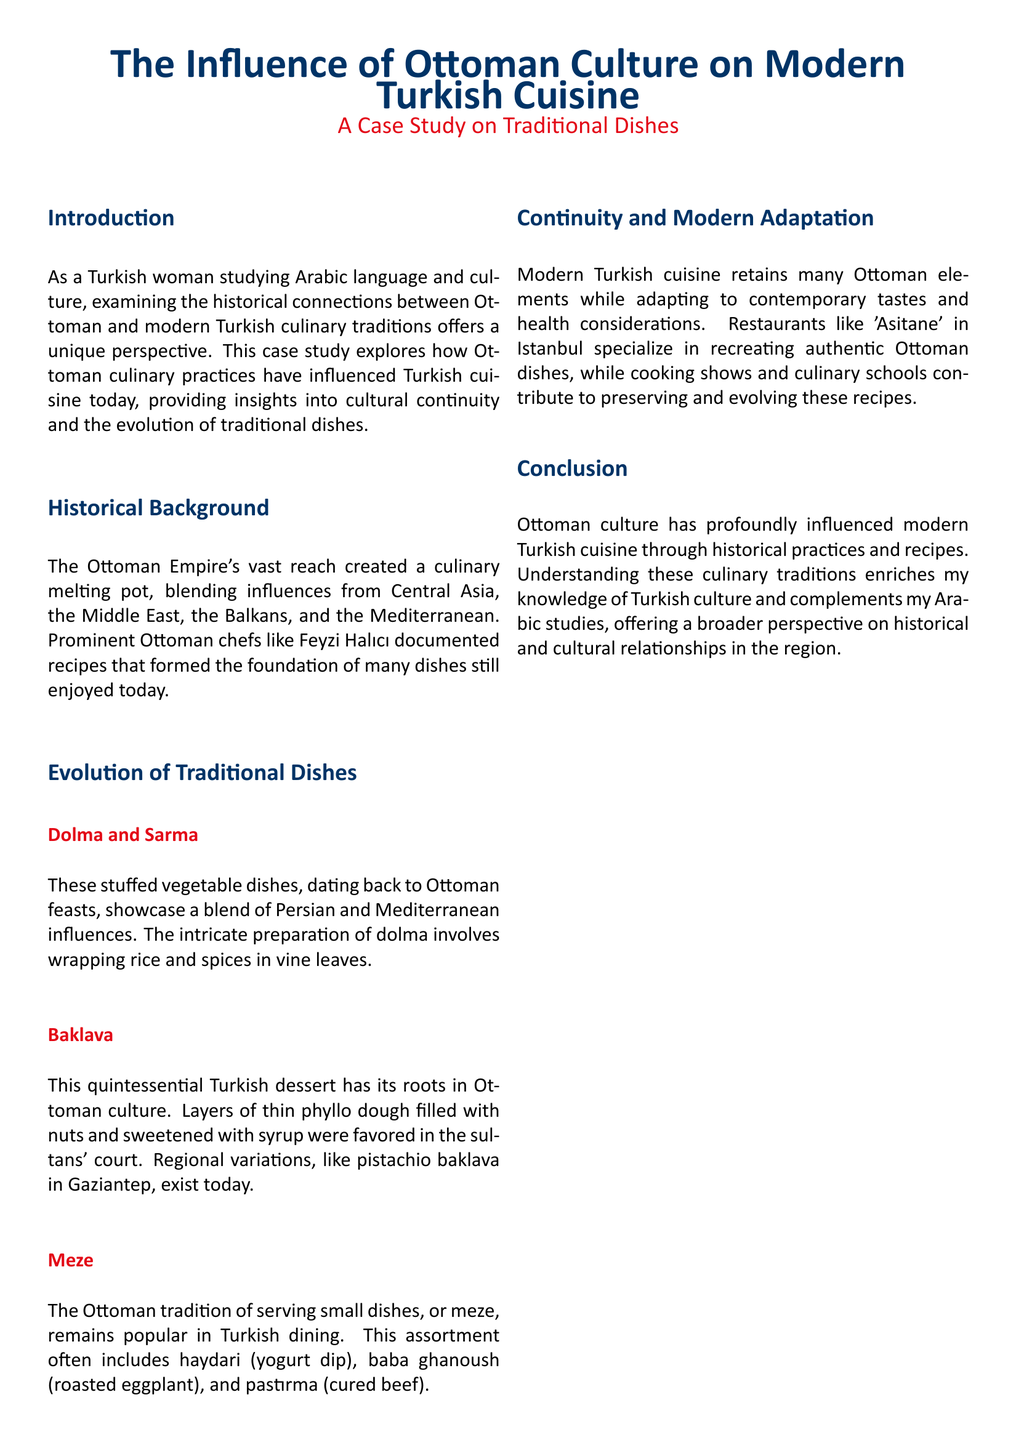What is the main focus of the case study? The case study focuses on the influence of Ottoman culture on modern Turkish cuisine by examining traditional dishes.
Answer: Influence of Ottoman culture on modern Turkish cuisine Who documented the recipes that formed the foundation of many dishes? Prominent Ottoman chefs like Feyzi Halıcı documented recipes that are foundational to many dishes today.
Answer: Feyzi Halıcı What type of dish are dolma and sarma? Dolma and sarma are stuffed vegetable dishes that date back to Ottoman feasts.
Answer: Stuffed vegetable dishes Which dessert is rooted in Ottoman culture? Baklava is the quintessential Turkish dessert with roots in Ottoman culture.
Answer: Baklava What is a common feature of modern Turkish cuisine? Modern Turkish cuisine retains many Ottoman elements and adapts to contemporary tastes.
Answer: Retains many Ottoman elements What is the name of the restaurant in Istanbul that specializes in Ottoman dishes? 'Asitane' is the restaurant in Istanbul that specializes in recreating authentic Ottoman dishes.
Answer: Asitane What are meze? Meze are small dishes served traditionally in Ottoman dining that remain popular today.
Answer: Small dishes What cultural influence does the study provide insights into? The study provides insights into cultural continuity and the evolution of traditional dishes.
Answer: Cultural continuity and evolution of traditional dishes How does this case study enrich the author's knowledge? Understanding these culinary traditions enriches the author's knowledge of Turkish culture and complements Arabic studies.
Answer: Turkish culture and Arabic studies 